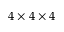Convert formula to latex. <formula><loc_0><loc_0><loc_500><loc_500>4 \times 4 \times 4</formula> 